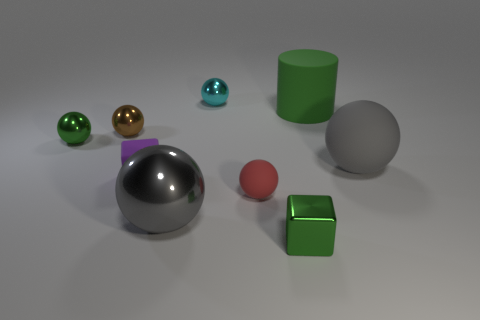Subtract all gray balls. How many were subtracted if there are1gray balls left? 1 Subtract all red balls. How many balls are left? 5 Subtract all blue cylinders. How many gray balls are left? 2 Subtract all brown balls. How many balls are left? 5 Add 1 shiny cubes. How many objects exist? 10 Subtract all spheres. How many objects are left? 3 Subtract all purple spheres. Subtract all blue cylinders. How many spheres are left? 6 Add 1 blue cylinders. How many blue cylinders exist? 1 Subtract 1 brown balls. How many objects are left? 8 Subtract all large cylinders. Subtract all tiny cyan metal cylinders. How many objects are left? 8 